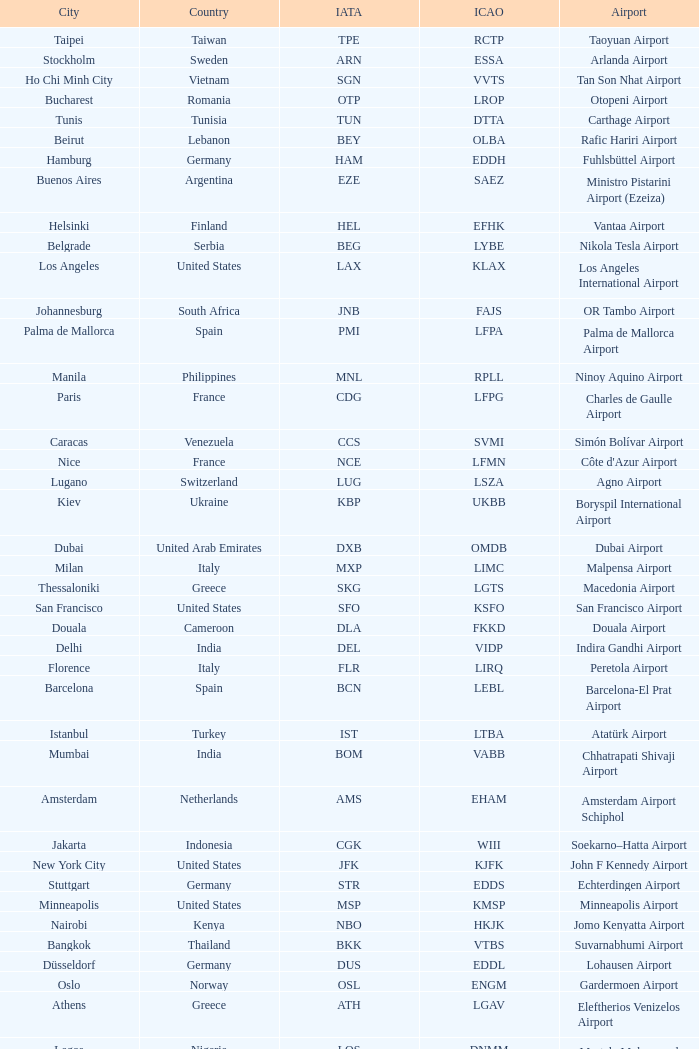What city is fuhlsbüttel airport in? Hamburg. 